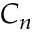Convert formula to latex. <formula><loc_0><loc_0><loc_500><loc_500>C _ { n }</formula> 